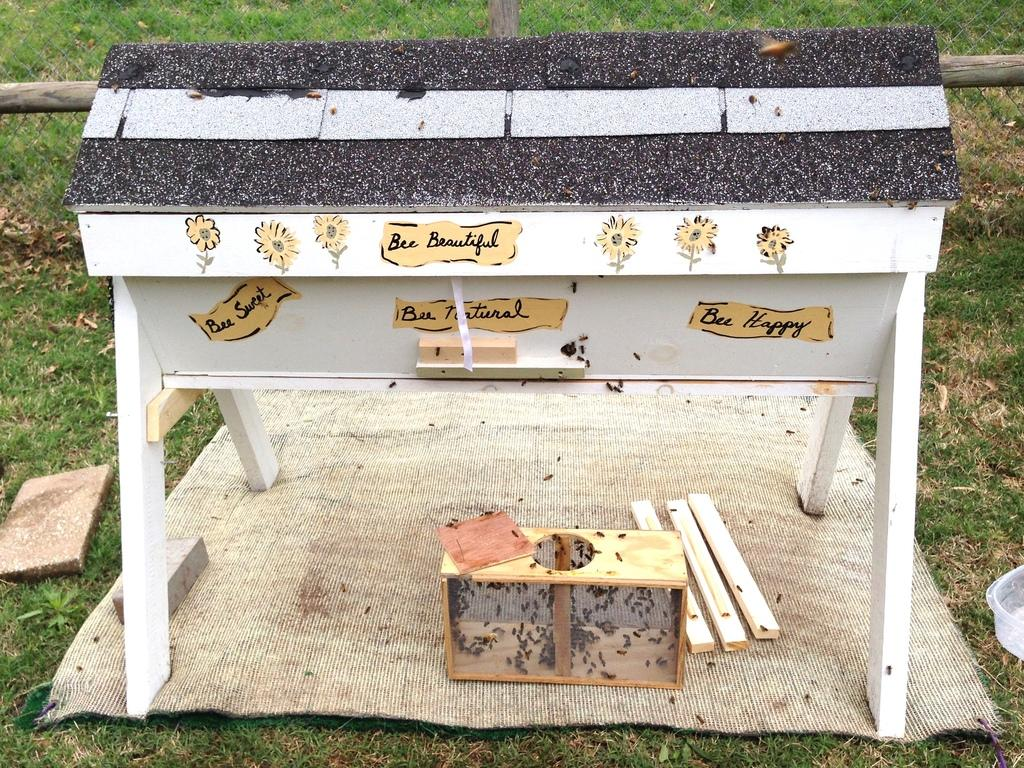<image>
Create a compact narrative representing the image presented. A custom made bee hive that says Bee Beautiful on it. 